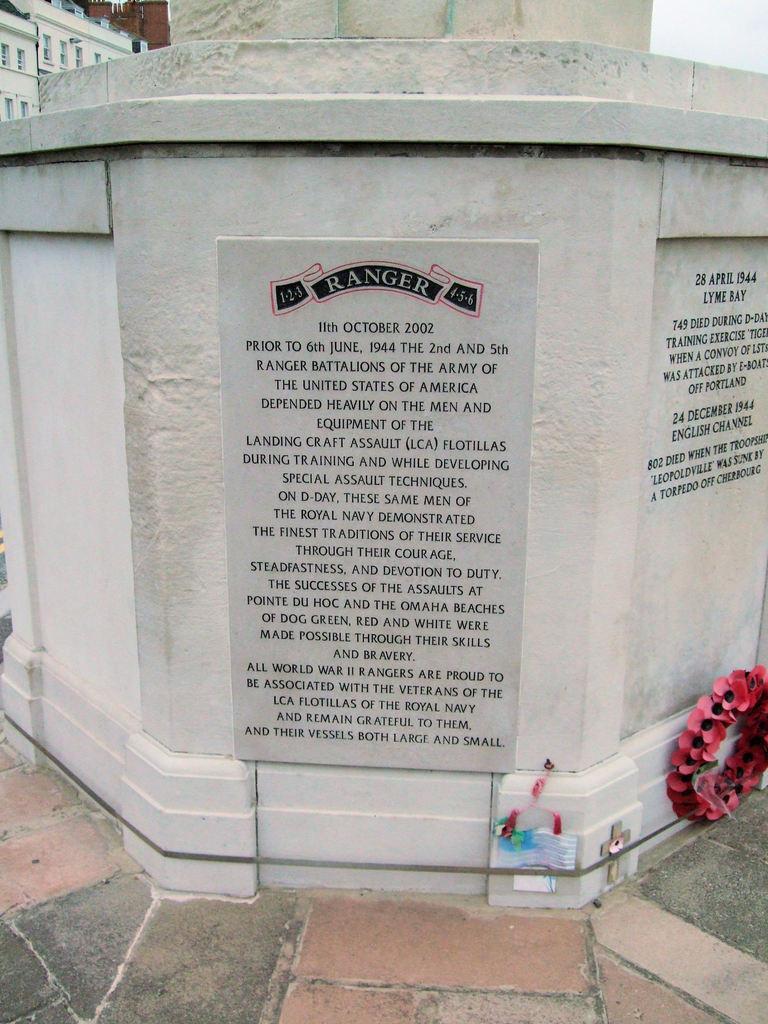Please provide a concise description of this image. In this image we can see memorials on a platform and at the bottom we can see a garland, cross symbol and objects on the platform. In the background there are buildings, windows and sky. 